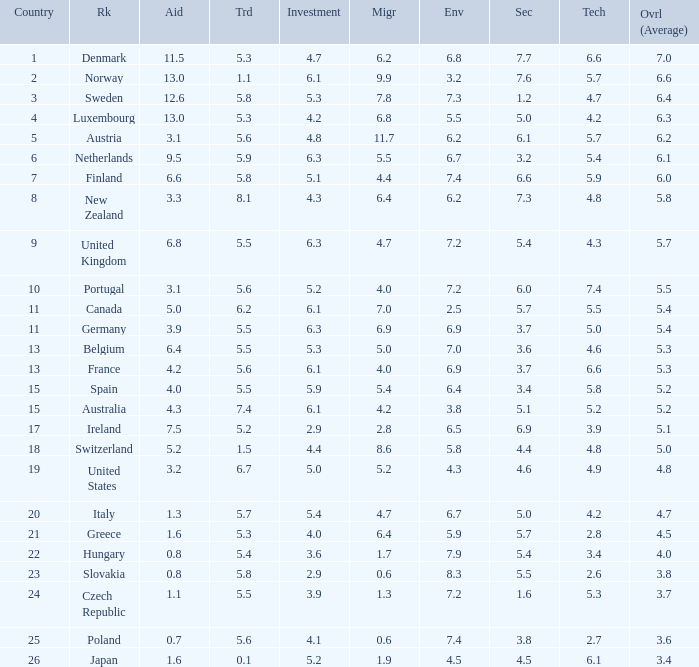How many times is denmark ranked in technology? 1.0. 